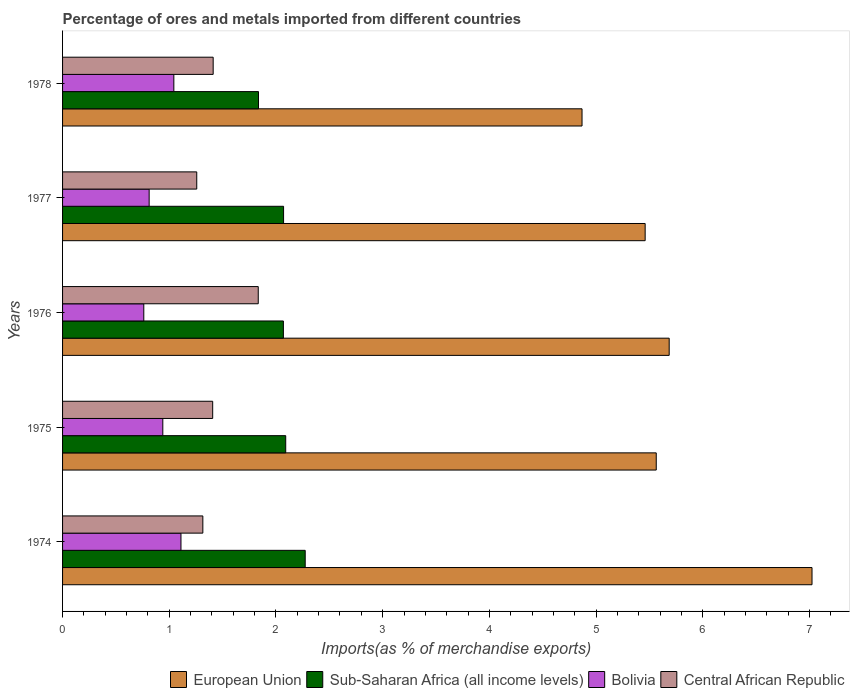Are the number of bars per tick equal to the number of legend labels?
Make the answer very short. Yes. How many bars are there on the 2nd tick from the top?
Keep it short and to the point. 4. How many bars are there on the 2nd tick from the bottom?
Ensure brevity in your answer.  4. What is the label of the 4th group of bars from the top?
Provide a succinct answer. 1975. What is the percentage of imports to different countries in Central African Republic in 1975?
Offer a terse response. 1.41. Across all years, what is the maximum percentage of imports to different countries in Bolivia?
Your answer should be compact. 1.11. Across all years, what is the minimum percentage of imports to different countries in European Union?
Make the answer very short. 4.87. In which year was the percentage of imports to different countries in Bolivia maximum?
Keep it short and to the point. 1974. In which year was the percentage of imports to different countries in Bolivia minimum?
Ensure brevity in your answer.  1976. What is the total percentage of imports to different countries in European Union in the graph?
Make the answer very short. 28.6. What is the difference between the percentage of imports to different countries in Sub-Saharan Africa (all income levels) in 1974 and that in 1975?
Keep it short and to the point. 0.18. What is the difference between the percentage of imports to different countries in Sub-Saharan Africa (all income levels) in 1977 and the percentage of imports to different countries in European Union in 1975?
Keep it short and to the point. -3.49. What is the average percentage of imports to different countries in Central African Republic per year?
Your response must be concise. 1.44. In the year 1975, what is the difference between the percentage of imports to different countries in European Union and percentage of imports to different countries in Bolivia?
Provide a short and direct response. 4.62. What is the ratio of the percentage of imports to different countries in European Union in 1976 to that in 1977?
Provide a succinct answer. 1.04. Is the percentage of imports to different countries in Central African Republic in 1974 less than that in 1976?
Keep it short and to the point. Yes. Is the difference between the percentage of imports to different countries in European Union in 1976 and 1977 greater than the difference between the percentage of imports to different countries in Bolivia in 1976 and 1977?
Provide a short and direct response. Yes. What is the difference between the highest and the second highest percentage of imports to different countries in Bolivia?
Offer a terse response. 0.07. What is the difference between the highest and the lowest percentage of imports to different countries in Sub-Saharan Africa (all income levels)?
Offer a terse response. 0.44. In how many years, is the percentage of imports to different countries in Central African Republic greater than the average percentage of imports to different countries in Central African Republic taken over all years?
Provide a succinct answer. 1. Is it the case that in every year, the sum of the percentage of imports to different countries in Central African Republic and percentage of imports to different countries in European Union is greater than the sum of percentage of imports to different countries in Bolivia and percentage of imports to different countries in Sub-Saharan Africa (all income levels)?
Your answer should be compact. Yes. What does the 3rd bar from the top in 1974 represents?
Offer a very short reply. Sub-Saharan Africa (all income levels). What does the 4th bar from the bottom in 1978 represents?
Provide a succinct answer. Central African Republic. How many bars are there?
Offer a terse response. 20. How many years are there in the graph?
Your answer should be very brief. 5. Are the values on the major ticks of X-axis written in scientific E-notation?
Your response must be concise. No. Does the graph contain any zero values?
Make the answer very short. No. Does the graph contain grids?
Ensure brevity in your answer.  No. What is the title of the graph?
Your answer should be compact. Percentage of ores and metals imported from different countries. Does "Belarus" appear as one of the legend labels in the graph?
Offer a very short reply. No. What is the label or title of the X-axis?
Give a very brief answer. Imports(as % of merchandise exports). What is the label or title of the Y-axis?
Offer a terse response. Years. What is the Imports(as % of merchandise exports) in European Union in 1974?
Provide a short and direct response. 7.02. What is the Imports(as % of merchandise exports) in Sub-Saharan Africa (all income levels) in 1974?
Your response must be concise. 2.27. What is the Imports(as % of merchandise exports) of Bolivia in 1974?
Your response must be concise. 1.11. What is the Imports(as % of merchandise exports) in Central African Republic in 1974?
Your response must be concise. 1.31. What is the Imports(as % of merchandise exports) in European Union in 1975?
Your answer should be very brief. 5.56. What is the Imports(as % of merchandise exports) of Sub-Saharan Africa (all income levels) in 1975?
Offer a very short reply. 2.09. What is the Imports(as % of merchandise exports) of Bolivia in 1975?
Provide a short and direct response. 0.94. What is the Imports(as % of merchandise exports) in Central African Republic in 1975?
Your response must be concise. 1.41. What is the Imports(as % of merchandise exports) of European Union in 1976?
Your answer should be very brief. 5.69. What is the Imports(as % of merchandise exports) of Sub-Saharan Africa (all income levels) in 1976?
Make the answer very short. 2.07. What is the Imports(as % of merchandise exports) in Bolivia in 1976?
Your answer should be very brief. 0.76. What is the Imports(as % of merchandise exports) of Central African Republic in 1976?
Your response must be concise. 1.83. What is the Imports(as % of merchandise exports) in European Union in 1977?
Keep it short and to the point. 5.46. What is the Imports(as % of merchandise exports) of Sub-Saharan Africa (all income levels) in 1977?
Your answer should be compact. 2.07. What is the Imports(as % of merchandise exports) in Bolivia in 1977?
Make the answer very short. 0.81. What is the Imports(as % of merchandise exports) of Central African Republic in 1977?
Keep it short and to the point. 1.26. What is the Imports(as % of merchandise exports) in European Union in 1978?
Your answer should be very brief. 4.87. What is the Imports(as % of merchandise exports) in Sub-Saharan Africa (all income levels) in 1978?
Make the answer very short. 1.84. What is the Imports(as % of merchandise exports) in Bolivia in 1978?
Provide a succinct answer. 1.04. What is the Imports(as % of merchandise exports) in Central African Republic in 1978?
Provide a succinct answer. 1.41. Across all years, what is the maximum Imports(as % of merchandise exports) in European Union?
Provide a short and direct response. 7.02. Across all years, what is the maximum Imports(as % of merchandise exports) of Sub-Saharan Africa (all income levels)?
Your response must be concise. 2.27. Across all years, what is the maximum Imports(as % of merchandise exports) in Bolivia?
Provide a short and direct response. 1.11. Across all years, what is the maximum Imports(as % of merchandise exports) of Central African Republic?
Your response must be concise. 1.83. Across all years, what is the minimum Imports(as % of merchandise exports) of European Union?
Offer a terse response. 4.87. Across all years, what is the minimum Imports(as % of merchandise exports) in Sub-Saharan Africa (all income levels)?
Keep it short and to the point. 1.84. Across all years, what is the minimum Imports(as % of merchandise exports) in Bolivia?
Your response must be concise. 0.76. Across all years, what is the minimum Imports(as % of merchandise exports) of Central African Republic?
Keep it short and to the point. 1.26. What is the total Imports(as % of merchandise exports) in European Union in the graph?
Provide a short and direct response. 28.6. What is the total Imports(as % of merchandise exports) in Sub-Saharan Africa (all income levels) in the graph?
Provide a succinct answer. 10.34. What is the total Imports(as % of merchandise exports) of Bolivia in the graph?
Your answer should be very brief. 4.66. What is the total Imports(as % of merchandise exports) of Central African Republic in the graph?
Make the answer very short. 7.22. What is the difference between the Imports(as % of merchandise exports) in European Union in 1974 and that in 1975?
Make the answer very short. 1.46. What is the difference between the Imports(as % of merchandise exports) of Sub-Saharan Africa (all income levels) in 1974 and that in 1975?
Make the answer very short. 0.18. What is the difference between the Imports(as % of merchandise exports) in Bolivia in 1974 and that in 1975?
Offer a very short reply. 0.17. What is the difference between the Imports(as % of merchandise exports) of Central African Republic in 1974 and that in 1975?
Make the answer very short. -0.09. What is the difference between the Imports(as % of merchandise exports) of European Union in 1974 and that in 1976?
Provide a short and direct response. 1.34. What is the difference between the Imports(as % of merchandise exports) of Sub-Saharan Africa (all income levels) in 1974 and that in 1976?
Offer a terse response. 0.2. What is the difference between the Imports(as % of merchandise exports) in Bolivia in 1974 and that in 1976?
Your response must be concise. 0.35. What is the difference between the Imports(as % of merchandise exports) of Central African Republic in 1974 and that in 1976?
Provide a short and direct response. -0.52. What is the difference between the Imports(as % of merchandise exports) of European Union in 1974 and that in 1977?
Your answer should be compact. 1.56. What is the difference between the Imports(as % of merchandise exports) of Sub-Saharan Africa (all income levels) in 1974 and that in 1977?
Your answer should be compact. 0.2. What is the difference between the Imports(as % of merchandise exports) in Bolivia in 1974 and that in 1977?
Give a very brief answer. 0.3. What is the difference between the Imports(as % of merchandise exports) of Central African Republic in 1974 and that in 1977?
Your answer should be compact. 0.06. What is the difference between the Imports(as % of merchandise exports) in European Union in 1974 and that in 1978?
Give a very brief answer. 2.16. What is the difference between the Imports(as % of merchandise exports) in Sub-Saharan Africa (all income levels) in 1974 and that in 1978?
Make the answer very short. 0.44. What is the difference between the Imports(as % of merchandise exports) in Bolivia in 1974 and that in 1978?
Your response must be concise. 0.07. What is the difference between the Imports(as % of merchandise exports) of Central African Republic in 1974 and that in 1978?
Make the answer very short. -0.1. What is the difference between the Imports(as % of merchandise exports) of European Union in 1975 and that in 1976?
Offer a very short reply. -0.12. What is the difference between the Imports(as % of merchandise exports) in Sub-Saharan Africa (all income levels) in 1975 and that in 1976?
Provide a succinct answer. 0.02. What is the difference between the Imports(as % of merchandise exports) in Bolivia in 1975 and that in 1976?
Offer a terse response. 0.18. What is the difference between the Imports(as % of merchandise exports) of Central African Republic in 1975 and that in 1976?
Your answer should be very brief. -0.43. What is the difference between the Imports(as % of merchandise exports) in European Union in 1975 and that in 1977?
Your answer should be compact. 0.1. What is the difference between the Imports(as % of merchandise exports) of Sub-Saharan Africa (all income levels) in 1975 and that in 1977?
Give a very brief answer. 0.02. What is the difference between the Imports(as % of merchandise exports) in Bolivia in 1975 and that in 1977?
Provide a succinct answer. 0.13. What is the difference between the Imports(as % of merchandise exports) of Central African Republic in 1975 and that in 1977?
Keep it short and to the point. 0.15. What is the difference between the Imports(as % of merchandise exports) in European Union in 1975 and that in 1978?
Your answer should be very brief. 0.7. What is the difference between the Imports(as % of merchandise exports) of Sub-Saharan Africa (all income levels) in 1975 and that in 1978?
Provide a succinct answer. 0.26. What is the difference between the Imports(as % of merchandise exports) in Bolivia in 1975 and that in 1978?
Offer a very short reply. -0.1. What is the difference between the Imports(as % of merchandise exports) of Central African Republic in 1975 and that in 1978?
Give a very brief answer. -0. What is the difference between the Imports(as % of merchandise exports) in European Union in 1976 and that in 1977?
Give a very brief answer. 0.23. What is the difference between the Imports(as % of merchandise exports) of Sub-Saharan Africa (all income levels) in 1976 and that in 1977?
Offer a very short reply. -0. What is the difference between the Imports(as % of merchandise exports) of Bolivia in 1976 and that in 1977?
Your response must be concise. -0.05. What is the difference between the Imports(as % of merchandise exports) in Central African Republic in 1976 and that in 1977?
Your answer should be compact. 0.58. What is the difference between the Imports(as % of merchandise exports) of European Union in 1976 and that in 1978?
Your response must be concise. 0.82. What is the difference between the Imports(as % of merchandise exports) in Sub-Saharan Africa (all income levels) in 1976 and that in 1978?
Offer a very short reply. 0.23. What is the difference between the Imports(as % of merchandise exports) of Bolivia in 1976 and that in 1978?
Offer a terse response. -0.28. What is the difference between the Imports(as % of merchandise exports) of Central African Republic in 1976 and that in 1978?
Your response must be concise. 0.42. What is the difference between the Imports(as % of merchandise exports) in European Union in 1977 and that in 1978?
Provide a succinct answer. 0.59. What is the difference between the Imports(as % of merchandise exports) in Sub-Saharan Africa (all income levels) in 1977 and that in 1978?
Your response must be concise. 0.23. What is the difference between the Imports(as % of merchandise exports) of Bolivia in 1977 and that in 1978?
Offer a very short reply. -0.23. What is the difference between the Imports(as % of merchandise exports) of Central African Republic in 1977 and that in 1978?
Provide a short and direct response. -0.15. What is the difference between the Imports(as % of merchandise exports) of European Union in 1974 and the Imports(as % of merchandise exports) of Sub-Saharan Africa (all income levels) in 1975?
Make the answer very short. 4.93. What is the difference between the Imports(as % of merchandise exports) in European Union in 1974 and the Imports(as % of merchandise exports) in Bolivia in 1975?
Your answer should be compact. 6.08. What is the difference between the Imports(as % of merchandise exports) of European Union in 1974 and the Imports(as % of merchandise exports) of Central African Republic in 1975?
Provide a short and direct response. 5.62. What is the difference between the Imports(as % of merchandise exports) in Sub-Saharan Africa (all income levels) in 1974 and the Imports(as % of merchandise exports) in Bolivia in 1975?
Provide a succinct answer. 1.33. What is the difference between the Imports(as % of merchandise exports) of Sub-Saharan Africa (all income levels) in 1974 and the Imports(as % of merchandise exports) of Central African Republic in 1975?
Keep it short and to the point. 0.87. What is the difference between the Imports(as % of merchandise exports) in Bolivia in 1974 and the Imports(as % of merchandise exports) in Central African Republic in 1975?
Your answer should be compact. -0.3. What is the difference between the Imports(as % of merchandise exports) of European Union in 1974 and the Imports(as % of merchandise exports) of Sub-Saharan Africa (all income levels) in 1976?
Your answer should be compact. 4.95. What is the difference between the Imports(as % of merchandise exports) in European Union in 1974 and the Imports(as % of merchandise exports) in Bolivia in 1976?
Your answer should be compact. 6.26. What is the difference between the Imports(as % of merchandise exports) in European Union in 1974 and the Imports(as % of merchandise exports) in Central African Republic in 1976?
Provide a short and direct response. 5.19. What is the difference between the Imports(as % of merchandise exports) in Sub-Saharan Africa (all income levels) in 1974 and the Imports(as % of merchandise exports) in Bolivia in 1976?
Provide a short and direct response. 1.51. What is the difference between the Imports(as % of merchandise exports) in Sub-Saharan Africa (all income levels) in 1974 and the Imports(as % of merchandise exports) in Central African Republic in 1976?
Offer a very short reply. 0.44. What is the difference between the Imports(as % of merchandise exports) in Bolivia in 1974 and the Imports(as % of merchandise exports) in Central African Republic in 1976?
Your answer should be compact. -0.72. What is the difference between the Imports(as % of merchandise exports) of European Union in 1974 and the Imports(as % of merchandise exports) of Sub-Saharan Africa (all income levels) in 1977?
Your answer should be compact. 4.95. What is the difference between the Imports(as % of merchandise exports) in European Union in 1974 and the Imports(as % of merchandise exports) in Bolivia in 1977?
Ensure brevity in your answer.  6.21. What is the difference between the Imports(as % of merchandise exports) of European Union in 1974 and the Imports(as % of merchandise exports) of Central African Republic in 1977?
Give a very brief answer. 5.77. What is the difference between the Imports(as % of merchandise exports) of Sub-Saharan Africa (all income levels) in 1974 and the Imports(as % of merchandise exports) of Bolivia in 1977?
Your answer should be very brief. 1.46. What is the difference between the Imports(as % of merchandise exports) in Sub-Saharan Africa (all income levels) in 1974 and the Imports(as % of merchandise exports) in Central African Republic in 1977?
Provide a succinct answer. 1.02. What is the difference between the Imports(as % of merchandise exports) in Bolivia in 1974 and the Imports(as % of merchandise exports) in Central African Republic in 1977?
Your answer should be compact. -0.15. What is the difference between the Imports(as % of merchandise exports) in European Union in 1974 and the Imports(as % of merchandise exports) in Sub-Saharan Africa (all income levels) in 1978?
Give a very brief answer. 5.19. What is the difference between the Imports(as % of merchandise exports) of European Union in 1974 and the Imports(as % of merchandise exports) of Bolivia in 1978?
Give a very brief answer. 5.98. What is the difference between the Imports(as % of merchandise exports) in European Union in 1974 and the Imports(as % of merchandise exports) in Central African Republic in 1978?
Make the answer very short. 5.61. What is the difference between the Imports(as % of merchandise exports) of Sub-Saharan Africa (all income levels) in 1974 and the Imports(as % of merchandise exports) of Bolivia in 1978?
Provide a short and direct response. 1.23. What is the difference between the Imports(as % of merchandise exports) in Sub-Saharan Africa (all income levels) in 1974 and the Imports(as % of merchandise exports) in Central African Republic in 1978?
Your response must be concise. 0.86. What is the difference between the Imports(as % of merchandise exports) of Bolivia in 1974 and the Imports(as % of merchandise exports) of Central African Republic in 1978?
Give a very brief answer. -0.3. What is the difference between the Imports(as % of merchandise exports) of European Union in 1975 and the Imports(as % of merchandise exports) of Sub-Saharan Africa (all income levels) in 1976?
Provide a short and direct response. 3.49. What is the difference between the Imports(as % of merchandise exports) in European Union in 1975 and the Imports(as % of merchandise exports) in Bolivia in 1976?
Offer a terse response. 4.8. What is the difference between the Imports(as % of merchandise exports) of European Union in 1975 and the Imports(as % of merchandise exports) of Central African Republic in 1976?
Make the answer very short. 3.73. What is the difference between the Imports(as % of merchandise exports) of Sub-Saharan Africa (all income levels) in 1975 and the Imports(as % of merchandise exports) of Bolivia in 1976?
Make the answer very short. 1.33. What is the difference between the Imports(as % of merchandise exports) in Sub-Saharan Africa (all income levels) in 1975 and the Imports(as % of merchandise exports) in Central African Republic in 1976?
Keep it short and to the point. 0.26. What is the difference between the Imports(as % of merchandise exports) of Bolivia in 1975 and the Imports(as % of merchandise exports) of Central African Republic in 1976?
Keep it short and to the point. -0.89. What is the difference between the Imports(as % of merchandise exports) of European Union in 1975 and the Imports(as % of merchandise exports) of Sub-Saharan Africa (all income levels) in 1977?
Offer a terse response. 3.49. What is the difference between the Imports(as % of merchandise exports) of European Union in 1975 and the Imports(as % of merchandise exports) of Bolivia in 1977?
Your answer should be very brief. 4.75. What is the difference between the Imports(as % of merchandise exports) in European Union in 1975 and the Imports(as % of merchandise exports) in Central African Republic in 1977?
Keep it short and to the point. 4.31. What is the difference between the Imports(as % of merchandise exports) in Sub-Saharan Africa (all income levels) in 1975 and the Imports(as % of merchandise exports) in Bolivia in 1977?
Provide a succinct answer. 1.28. What is the difference between the Imports(as % of merchandise exports) of Sub-Saharan Africa (all income levels) in 1975 and the Imports(as % of merchandise exports) of Central African Republic in 1977?
Offer a very short reply. 0.83. What is the difference between the Imports(as % of merchandise exports) in Bolivia in 1975 and the Imports(as % of merchandise exports) in Central African Republic in 1977?
Ensure brevity in your answer.  -0.32. What is the difference between the Imports(as % of merchandise exports) of European Union in 1975 and the Imports(as % of merchandise exports) of Sub-Saharan Africa (all income levels) in 1978?
Your answer should be compact. 3.73. What is the difference between the Imports(as % of merchandise exports) in European Union in 1975 and the Imports(as % of merchandise exports) in Bolivia in 1978?
Offer a terse response. 4.52. What is the difference between the Imports(as % of merchandise exports) of European Union in 1975 and the Imports(as % of merchandise exports) of Central African Republic in 1978?
Ensure brevity in your answer.  4.15. What is the difference between the Imports(as % of merchandise exports) of Sub-Saharan Africa (all income levels) in 1975 and the Imports(as % of merchandise exports) of Bolivia in 1978?
Your answer should be compact. 1.05. What is the difference between the Imports(as % of merchandise exports) of Sub-Saharan Africa (all income levels) in 1975 and the Imports(as % of merchandise exports) of Central African Republic in 1978?
Your response must be concise. 0.68. What is the difference between the Imports(as % of merchandise exports) in Bolivia in 1975 and the Imports(as % of merchandise exports) in Central African Republic in 1978?
Your answer should be compact. -0.47. What is the difference between the Imports(as % of merchandise exports) of European Union in 1976 and the Imports(as % of merchandise exports) of Sub-Saharan Africa (all income levels) in 1977?
Provide a short and direct response. 3.61. What is the difference between the Imports(as % of merchandise exports) in European Union in 1976 and the Imports(as % of merchandise exports) in Bolivia in 1977?
Make the answer very short. 4.87. What is the difference between the Imports(as % of merchandise exports) in European Union in 1976 and the Imports(as % of merchandise exports) in Central African Republic in 1977?
Your answer should be compact. 4.43. What is the difference between the Imports(as % of merchandise exports) in Sub-Saharan Africa (all income levels) in 1976 and the Imports(as % of merchandise exports) in Bolivia in 1977?
Make the answer very short. 1.26. What is the difference between the Imports(as % of merchandise exports) in Sub-Saharan Africa (all income levels) in 1976 and the Imports(as % of merchandise exports) in Central African Republic in 1977?
Offer a very short reply. 0.81. What is the difference between the Imports(as % of merchandise exports) of Bolivia in 1976 and the Imports(as % of merchandise exports) of Central African Republic in 1977?
Keep it short and to the point. -0.5. What is the difference between the Imports(as % of merchandise exports) in European Union in 1976 and the Imports(as % of merchandise exports) in Sub-Saharan Africa (all income levels) in 1978?
Provide a short and direct response. 3.85. What is the difference between the Imports(as % of merchandise exports) of European Union in 1976 and the Imports(as % of merchandise exports) of Bolivia in 1978?
Keep it short and to the point. 4.64. What is the difference between the Imports(as % of merchandise exports) in European Union in 1976 and the Imports(as % of merchandise exports) in Central African Republic in 1978?
Offer a very short reply. 4.27. What is the difference between the Imports(as % of merchandise exports) in Sub-Saharan Africa (all income levels) in 1976 and the Imports(as % of merchandise exports) in Bolivia in 1978?
Ensure brevity in your answer.  1.03. What is the difference between the Imports(as % of merchandise exports) of Sub-Saharan Africa (all income levels) in 1976 and the Imports(as % of merchandise exports) of Central African Republic in 1978?
Provide a succinct answer. 0.66. What is the difference between the Imports(as % of merchandise exports) of Bolivia in 1976 and the Imports(as % of merchandise exports) of Central African Republic in 1978?
Your answer should be very brief. -0.65. What is the difference between the Imports(as % of merchandise exports) in European Union in 1977 and the Imports(as % of merchandise exports) in Sub-Saharan Africa (all income levels) in 1978?
Give a very brief answer. 3.62. What is the difference between the Imports(as % of merchandise exports) of European Union in 1977 and the Imports(as % of merchandise exports) of Bolivia in 1978?
Give a very brief answer. 4.42. What is the difference between the Imports(as % of merchandise exports) in European Union in 1977 and the Imports(as % of merchandise exports) in Central African Republic in 1978?
Your response must be concise. 4.05. What is the difference between the Imports(as % of merchandise exports) of Sub-Saharan Africa (all income levels) in 1977 and the Imports(as % of merchandise exports) of Bolivia in 1978?
Offer a terse response. 1.03. What is the difference between the Imports(as % of merchandise exports) of Sub-Saharan Africa (all income levels) in 1977 and the Imports(as % of merchandise exports) of Central African Republic in 1978?
Ensure brevity in your answer.  0.66. What is the average Imports(as % of merchandise exports) of European Union per year?
Give a very brief answer. 5.72. What is the average Imports(as % of merchandise exports) of Sub-Saharan Africa (all income levels) per year?
Your response must be concise. 2.07. What is the average Imports(as % of merchandise exports) in Bolivia per year?
Provide a short and direct response. 0.93. What is the average Imports(as % of merchandise exports) of Central African Republic per year?
Ensure brevity in your answer.  1.44. In the year 1974, what is the difference between the Imports(as % of merchandise exports) in European Union and Imports(as % of merchandise exports) in Sub-Saharan Africa (all income levels)?
Your response must be concise. 4.75. In the year 1974, what is the difference between the Imports(as % of merchandise exports) of European Union and Imports(as % of merchandise exports) of Bolivia?
Keep it short and to the point. 5.91. In the year 1974, what is the difference between the Imports(as % of merchandise exports) in European Union and Imports(as % of merchandise exports) in Central African Republic?
Your answer should be compact. 5.71. In the year 1974, what is the difference between the Imports(as % of merchandise exports) in Sub-Saharan Africa (all income levels) and Imports(as % of merchandise exports) in Bolivia?
Make the answer very short. 1.16. In the year 1974, what is the difference between the Imports(as % of merchandise exports) of Sub-Saharan Africa (all income levels) and Imports(as % of merchandise exports) of Central African Republic?
Provide a short and direct response. 0.96. In the year 1974, what is the difference between the Imports(as % of merchandise exports) in Bolivia and Imports(as % of merchandise exports) in Central African Republic?
Your response must be concise. -0.2. In the year 1975, what is the difference between the Imports(as % of merchandise exports) in European Union and Imports(as % of merchandise exports) in Sub-Saharan Africa (all income levels)?
Keep it short and to the point. 3.47. In the year 1975, what is the difference between the Imports(as % of merchandise exports) in European Union and Imports(as % of merchandise exports) in Bolivia?
Your response must be concise. 4.62. In the year 1975, what is the difference between the Imports(as % of merchandise exports) in European Union and Imports(as % of merchandise exports) in Central African Republic?
Your response must be concise. 4.16. In the year 1975, what is the difference between the Imports(as % of merchandise exports) of Sub-Saharan Africa (all income levels) and Imports(as % of merchandise exports) of Bolivia?
Provide a short and direct response. 1.15. In the year 1975, what is the difference between the Imports(as % of merchandise exports) of Sub-Saharan Africa (all income levels) and Imports(as % of merchandise exports) of Central African Republic?
Offer a very short reply. 0.68. In the year 1975, what is the difference between the Imports(as % of merchandise exports) in Bolivia and Imports(as % of merchandise exports) in Central African Republic?
Offer a terse response. -0.47. In the year 1976, what is the difference between the Imports(as % of merchandise exports) in European Union and Imports(as % of merchandise exports) in Sub-Saharan Africa (all income levels)?
Offer a very short reply. 3.62. In the year 1976, what is the difference between the Imports(as % of merchandise exports) in European Union and Imports(as % of merchandise exports) in Bolivia?
Keep it short and to the point. 4.92. In the year 1976, what is the difference between the Imports(as % of merchandise exports) in European Union and Imports(as % of merchandise exports) in Central African Republic?
Offer a very short reply. 3.85. In the year 1976, what is the difference between the Imports(as % of merchandise exports) in Sub-Saharan Africa (all income levels) and Imports(as % of merchandise exports) in Bolivia?
Give a very brief answer. 1.31. In the year 1976, what is the difference between the Imports(as % of merchandise exports) of Sub-Saharan Africa (all income levels) and Imports(as % of merchandise exports) of Central African Republic?
Give a very brief answer. 0.24. In the year 1976, what is the difference between the Imports(as % of merchandise exports) in Bolivia and Imports(as % of merchandise exports) in Central African Republic?
Provide a succinct answer. -1.07. In the year 1977, what is the difference between the Imports(as % of merchandise exports) of European Union and Imports(as % of merchandise exports) of Sub-Saharan Africa (all income levels)?
Make the answer very short. 3.39. In the year 1977, what is the difference between the Imports(as % of merchandise exports) in European Union and Imports(as % of merchandise exports) in Bolivia?
Your response must be concise. 4.65. In the year 1977, what is the difference between the Imports(as % of merchandise exports) in European Union and Imports(as % of merchandise exports) in Central African Republic?
Give a very brief answer. 4.2. In the year 1977, what is the difference between the Imports(as % of merchandise exports) in Sub-Saharan Africa (all income levels) and Imports(as % of merchandise exports) in Bolivia?
Your response must be concise. 1.26. In the year 1977, what is the difference between the Imports(as % of merchandise exports) in Sub-Saharan Africa (all income levels) and Imports(as % of merchandise exports) in Central African Republic?
Ensure brevity in your answer.  0.81. In the year 1977, what is the difference between the Imports(as % of merchandise exports) of Bolivia and Imports(as % of merchandise exports) of Central African Republic?
Offer a terse response. -0.45. In the year 1978, what is the difference between the Imports(as % of merchandise exports) in European Union and Imports(as % of merchandise exports) in Sub-Saharan Africa (all income levels)?
Your answer should be compact. 3.03. In the year 1978, what is the difference between the Imports(as % of merchandise exports) of European Union and Imports(as % of merchandise exports) of Bolivia?
Ensure brevity in your answer.  3.83. In the year 1978, what is the difference between the Imports(as % of merchandise exports) of European Union and Imports(as % of merchandise exports) of Central African Republic?
Make the answer very short. 3.46. In the year 1978, what is the difference between the Imports(as % of merchandise exports) in Sub-Saharan Africa (all income levels) and Imports(as % of merchandise exports) in Bolivia?
Your answer should be very brief. 0.79. In the year 1978, what is the difference between the Imports(as % of merchandise exports) of Sub-Saharan Africa (all income levels) and Imports(as % of merchandise exports) of Central African Republic?
Make the answer very short. 0.42. In the year 1978, what is the difference between the Imports(as % of merchandise exports) of Bolivia and Imports(as % of merchandise exports) of Central African Republic?
Offer a very short reply. -0.37. What is the ratio of the Imports(as % of merchandise exports) in European Union in 1974 to that in 1975?
Offer a very short reply. 1.26. What is the ratio of the Imports(as % of merchandise exports) of Sub-Saharan Africa (all income levels) in 1974 to that in 1975?
Your answer should be very brief. 1.09. What is the ratio of the Imports(as % of merchandise exports) of Bolivia in 1974 to that in 1975?
Offer a terse response. 1.18. What is the ratio of the Imports(as % of merchandise exports) in Central African Republic in 1974 to that in 1975?
Provide a succinct answer. 0.93. What is the ratio of the Imports(as % of merchandise exports) of European Union in 1974 to that in 1976?
Keep it short and to the point. 1.24. What is the ratio of the Imports(as % of merchandise exports) in Sub-Saharan Africa (all income levels) in 1974 to that in 1976?
Your response must be concise. 1.1. What is the ratio of the Imports(as % of merchandise exports) in Bolivia in 1974 to that in 1976?
Ensure brevity in your answer.  1.46. What is the ratio of the Imports(as % of merchandise exports) of Central African Republic in 1974 to that in 1976?
Provide a short and direct response. 0.72. What is the ratio of the Imports(as % of merchandise exports) in European Union in 1974 to that in 1977?
Your answer should be very brief. 1.29. What is the ratio of the Imports(as % of merchandise exports) of Sub-Saharan Africa (all income levels) in 1974 to that in 1977?
Keep it short and to the point. 1.1. What is the ratio of the Imports(as % of merchandise exports) in Bolivia in 1974 to that in 1977?
Make the answer very short. 1.37. What is the ratio of the Imports(as % of merchandise exports) of Central African Republic in 1974 to that in 1977?
Offer a very short reply. 1.05. What is the ratio of the Imports(as % of merchandise exports) of European Union in 1974 to that in 1978?
Ensure brevity in your answer.  1.44. What is the ratio of the Imports(as % of merchandise exports) of Sub-Saharan Africa (all income levels) in 1974 to that in 1978?
Provide a short and direct response. 1.24. What is the ratio of the Imports(as % of merchandise exports) in Bolivia in 1974 to that in 1978?
Provide a succinct answer. 1.06. What is the ratio of the Imports(as % of merchandise exports) in Central African Republic in 1974 to that in 1978?
Provide a succinct answer. 0.93. What is the ratio of the Imports(as % of merchandise exports) of European Union in 1975 to that in 1976?
Keep it short and to the point. 0.98. What is the ratio of the Imports(as % of merchandise exports) of Sub-Saharan Africa (all income levels) in 1975 to that in 1976?
Offer a very short reply. 1.01. What is the ratio of the Imports(as % of merchandise exports) of Bolivia in 1975 to that in 1976?
Provide a short and direct response. 1.23. What is the ratio of the Imports(as % of merchandise exports) of Central African Republic in 1975 to that in 1976?
Make the answer very short. 0.77. What is the ratio of the Imports(as % of merchandise exports) in European Union in 1975 to that in 1977?
Provide a succinct answer. 1.02. What is the ratio of the Imports(as % of merchandise exports) in Sub-Saharan Africa (all income levels) in 1975 to that in 1977?
Make the answer very short. 1.01. What is the ratio of the Imports(as % of merchandise exports) of Bolivia in 1975 to that in 1977?
Offer a very short reply. 1.16. What is the ratio of the Imports(as % of merchandise exports) of Central African Republic in 1975 to that in 1977?
Offer a terse response. 1.12. What is the ratio of the Imports(as % of merchandise exports) in European Union in 1975 to that in 1978?
Your response must be concise. 1.14. What is the ratio of the Imports(as % of merchandise exports) in Sub-Saharan Africa (all income levels) in 1975 to that in 1978?
Your answer should be compact. 1.14. What is the ratio of the Imports(as % of merchandise exports) in Bolivia in 1975 to that in 1978?
Offer a very short reply. 0.9. What is the ratio of the Imports(as % of merchandise exports) of European Union in 1976 to that in 1977?
Keep it short and to the point. 1.04. What is the ratio of the Imports(as % of merchandise exports) of Bolivia in 1976 to that in 1977?
Your answer should be compact. 0.94. What is the ratio of the Imports(as % of merchandise exports) in Central African Republic in 1976 to that in 1977?
Ensure brevity in your answer.  1.46. What is the ratio of the Imports(as % of merchandise exports) in European Union in 1976 to that in 1978?
Your response must be concise. 1.17. What is the ratio of the Imports(as % of merchandise exports) in Sub-Saharan Africa (all income levels) in 1976 to that in 1978?
Your response must be concise. 1.13. What is the ratio of the Imports(as % of merchandise exports) in Bolivia in 1976 to that in 1978?
Offer a very short reply. 0.73. What is the ratio of the Imports(as % of merchandise exports) of Central African Republic in 1976 to that in 1978?
Ensure brevity in your answer.  1.3. What is the ratio of the Imports(as % of merchandise exports) in European Union in 1977 to that in 1978?
Provide a succinct answer. 1.12. What is the ratio of the Imports(as % of merchandise exports) in Sub-Saharan Africa (all income levels) in 1977 to that in 1978?
Your answer should be compact. 1.13. What is the ratio of the Imports(as % of merchandise exports) of Bolivia in 1977 to that in 1978?
Ensure brevity in your answer.  0.78. What is the ratio of the Imports(as % of merchandise exports) of Central African Republic in 1977 to that in 1978?
Your answer should be compact. 0.89. What is the difference between the highest and the second highest Imports(as % of merchandise exports) of European Union?
Keep it short and to the point. 1.34. What is the difference between the highest and the second highest Imports(as % of merchandise exports) of Sub-Saharan Africa (all income levels)?
Offer a terse response. 0.18. What is the difference between the highest and the second highest Imports(as % of merchandise exports) of Bolivia?
Keep it short and to the point. 0.07. What is the difference between the highest and the second highest Imports(as % of merchandise exports) of Central African Republic?
Offer a terse response. 0.42. What is the difference between the highest and the lowest Imports(as % of merchandise exports) in European Union?
Give a very brief answer. 2.16. What is the difference between the highest and the lowest Imports(as % of merchandise exports) of Sub-Saharan Africa (all income levels)?
Your response must be concise. 0.44. What is the difference between the highest and the lowest Imports(as % of merchandise exports) of Bolivia?
Make the answer very short. 0.35. What is the difference between the highest and the lowest Imports(as % of merchandise exports) in Central African Republic?
Provide a short and direct response. 0.58. 